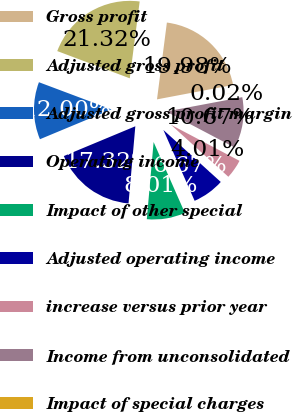<chart> <loc_0><loc_0><loc_500><loc_500><pie_chart><fcel>Gross profit<fcel>Adjusted gross profit<fcel>Adjusted gross profit margin<fcel>Operating income<fcel>Impact of other special<fcel>Adjusted operating income<fcel>increase versus prior year<fcel>Income from unconsolidated<fcel>Impact of special charges<nl><fcel>19.98%<fcel>21.32%<fcel>12.0%<fcel>17.32%<fcel>8.01%<fcel>6.67%<fcel>4.01%<fcel>10.67%<fcel>0.02%<nl></chart> 